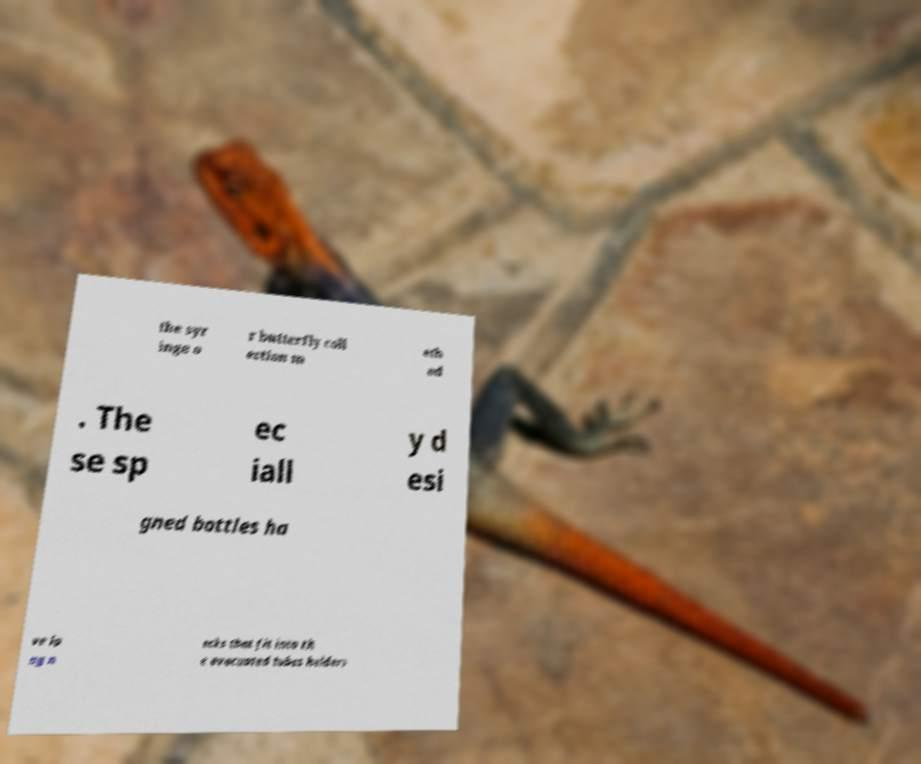Can you read and provide the text displayed in the image?This photo seems to have some interesting text. Can you extract and type it out for me? the syr inge o r butterfly coll ection m eth od . The se sp ec iall y d esi gned bottles ha ve lo ng n ecks that fit into th e evacuated tubes holders 